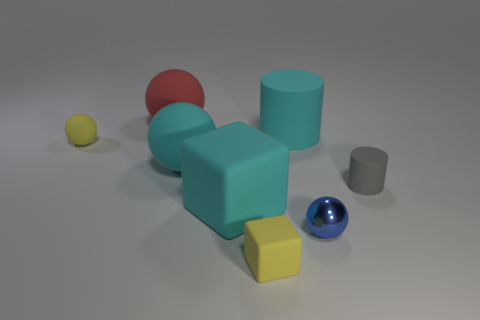Subtract all big red matte spheres. How many spheres are left? 3 Subtract 1 cylinders. How many cylinders are left? 1 Subtract all blue balls. How many balls are left? 3 Add 2 big red balls. How many objects exist? 10 Subtract 1 gray cylinders. How many objects are left? 7 Subtract all cylinders. How many objects are left? 6 Subtract all green blocks. Subtract all purple cylinders. How many blocks are left? 2 Subtract all green cubes. How many gray cylinders are left? 1 Subtract all tiny rubber cylinders. Subtract all big purple rubber cubes. How many objects are left? 7 Add 1 yellow matte cubes. How many yellow matte cubes are left? 2 